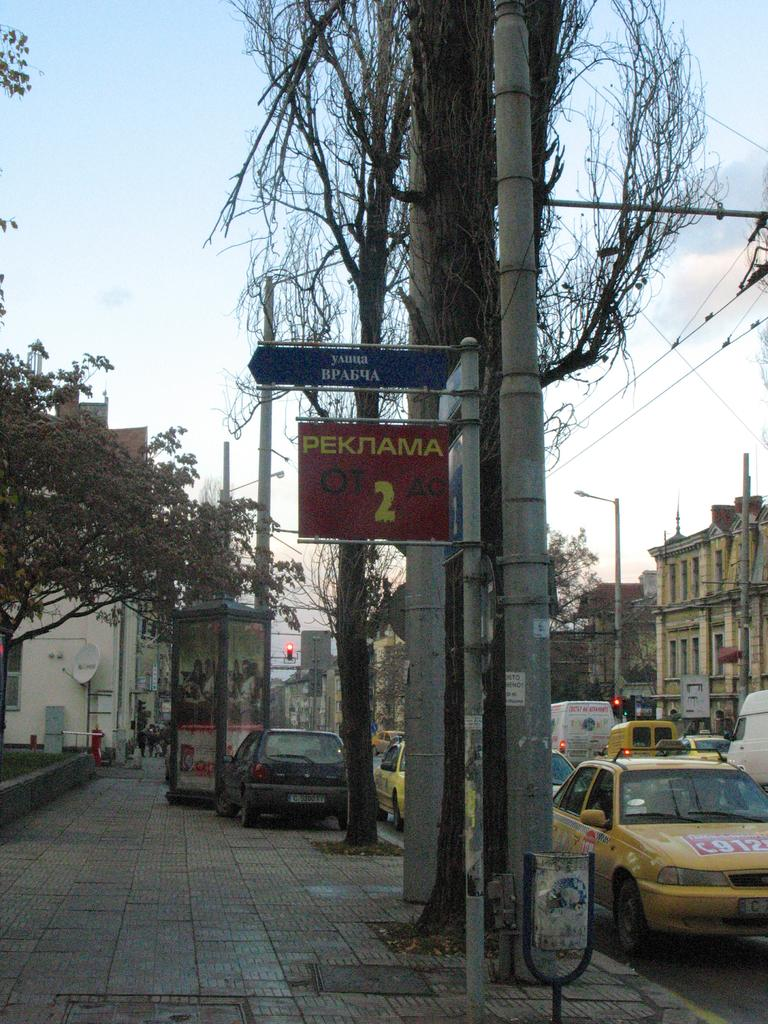<image>
Create a compact narrative representing the image presented. A red sign is hanging that says Peknama 2 and cars are parked next to it. 